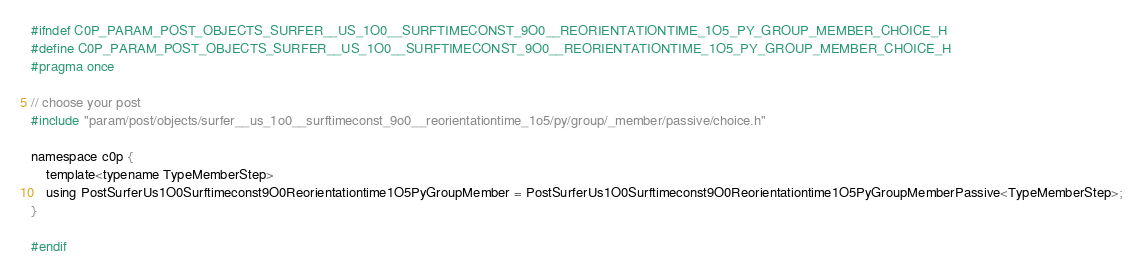<code> <loc_0><loc_0><loc_500><loc_500><_C_>#ifndef C0P_PARAM_POST_OBJECTS_SURFER__US_1O0__SURFTIMECONST_9O0__REORIENTATIONTIME_1O5_PY_GROUP_MEMBER_CHOICE_H
#define C0P_PARAM_POST_OBJECTS_SURFER__US_1O0__SURFTIMECONST_9O0__REORIENTATIONTIME_1O5_PY_GROUP_MEMBER_CHOICE_H
#pragma once

// choose your post
#include "param/post/objects/surfer__us_1o0__surftimeconst_9o0__reorientationtime_1o5/py/group/_member/passive/choice.h"

namespace c0p {
    template<typename TypeMemberStep>
    using PostSurferUs1O0Surftimeconst9O0Reorientationtime1O5PyGroupMember = PostSurferUs1O0Surftimeconst9O0Reorientationtime1O5PyGroupMemberPassive<TypeMemberStep>;
}

#endif
</code> 